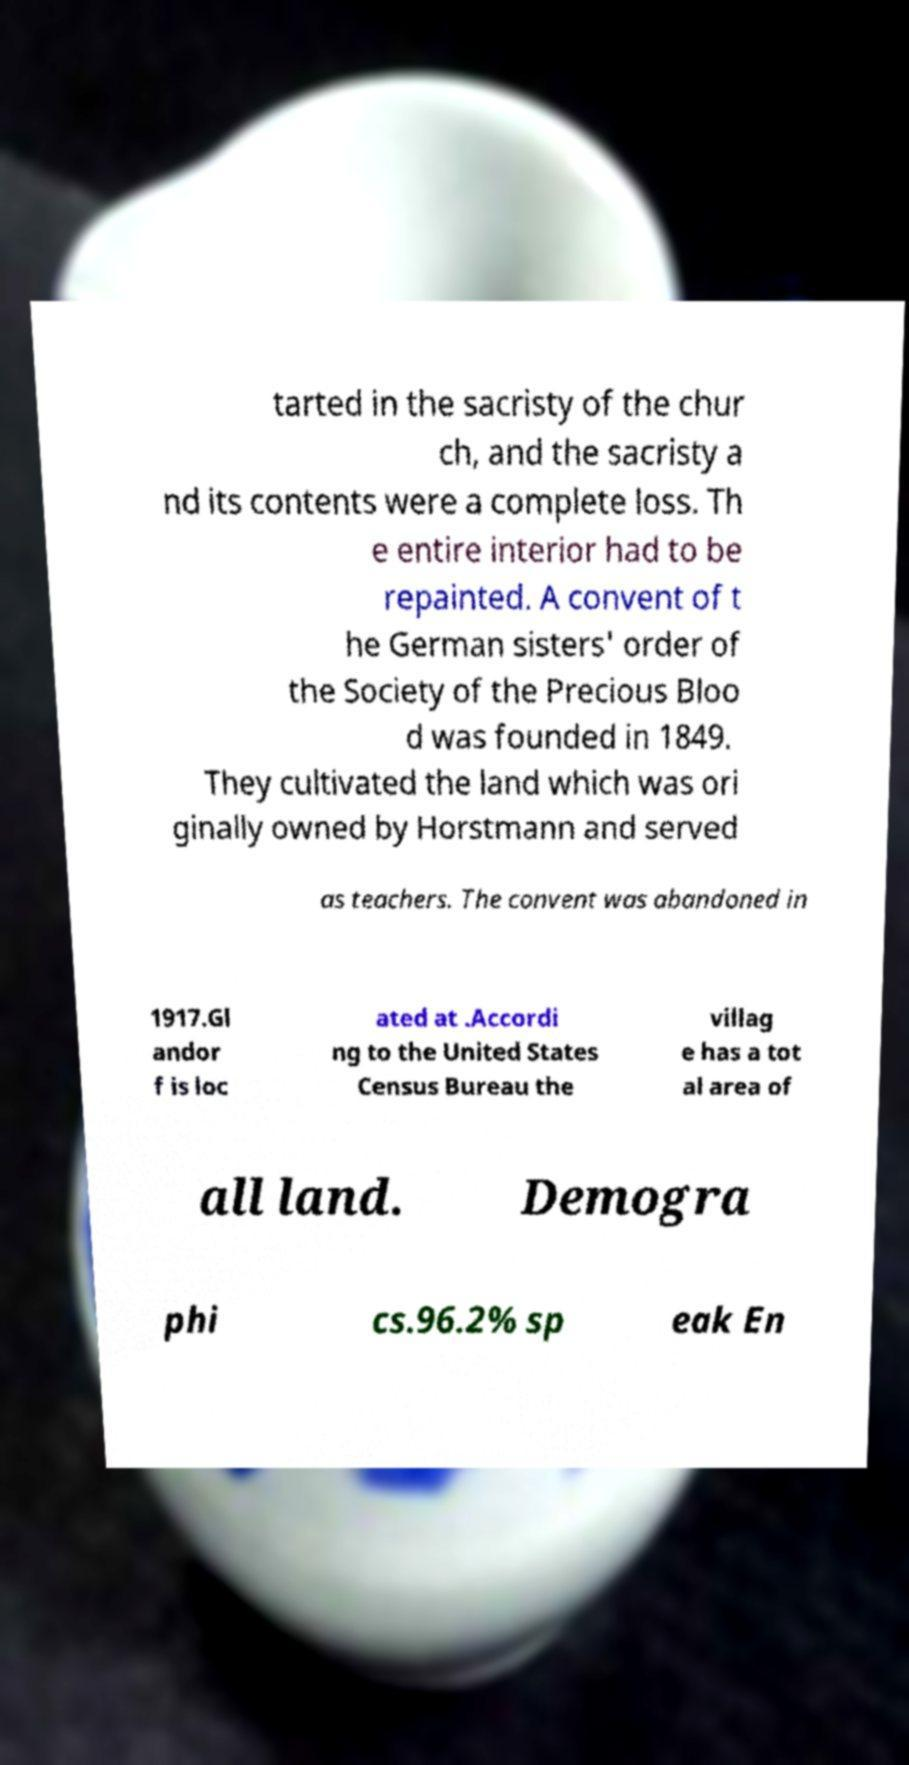Can you read and provide the text displayed in the image?This photo seems to have some interesting text. Can you extract and type it out for me? tarted in the sacristy of the chur ch, and the sacristy a nd its contents were a complete loss. Th e entire interior had to be repainted. A convent of t he German sisters' order of the Society of the Precious Bloo d was founded in 1849. They cultivated the land which was ori ginally owned by Horstmann and served as teachers. The convent was abandoned in 1917.Gl andor f is loc ated at .Accordi ng to the United States Census Bureau the villag e has a tot al area of all land. Demogra phi cs.96.2% sp eak En 